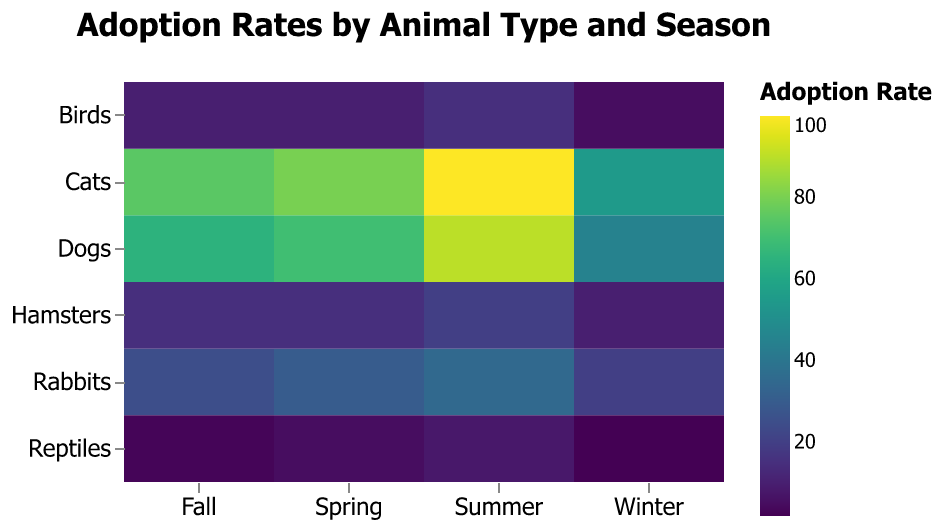What's the title of the heatmap? The title is located at the top of the heatmap and reads "Adoption Rates by Animal Type and Season".
Answer: Adoption Rates by Animal Type and Season Which animal type has the highest adoption rate in summer? Looking at the summer column, the highest value is 100 for Cats.
Answer: Cats What is the total adoption rate for Dogs across all seasons? Add the adoption rates for Dogs in Winter (45), Spring (70), Summer (90), and Fall (65). The total is 45 + 70 + 90 + 65 = 270.
Answer: 270 How does the adoption rate of Rabbits in Fall compare to their rate in Spring? The adoption rate for Rabbits in Fall is 25, and in Spring, it is 30. 25 is less than 30.
Answer: Less than Among the animal types listed, which one has the lowest adoption rate in any season and what is it? The lowest adoption rate is identified by scanning all the values. Reptiles in Winter have the lowest adoption rate, with a value of 2.
Answer: Reptiles, 2 Which season has the highest average adoption rate for all animals? Calculate the average adoption rate for each season: Winter (45+55+20+10+5+2)/6=22.83, Spring (70+80+30+15+10+5)/6=35, Summer (90+100+35+20+15+8)/6=44.67, Fall (65+75+25+15+10+3)/6=32.17. Summer has the highest average with 44.67.
Answer: Summer What is the difference in the adoption rate between Cats and Hamsters in Spring? The adoption rate for Cats in Spring is 80, and for Hamsters, it is 15. The difference is 80 - 15 = 65.
Answer: 65 What is the adoption rate for Birds in Winter? Find the value under Birds and Winter, which is 5.
Answer: 5 Which animal type has the most variation in adoption rates across the seasons? To determine this, calculate the range (max value - min value) for each animal type: 
- Dogs: 90 - 45 = 45 
- Cats: 100 - 55 = 45 
- Rabbits: 35 - 20 = 15 
- Hamsters: 20 - 10 = 10 
- Birds: 15 - 5 = 10 
- Reptiles: 8 - 2 = 6. Dogs and Cats have the most variation, with a range of 45.
Answer: Dogs and Cats 